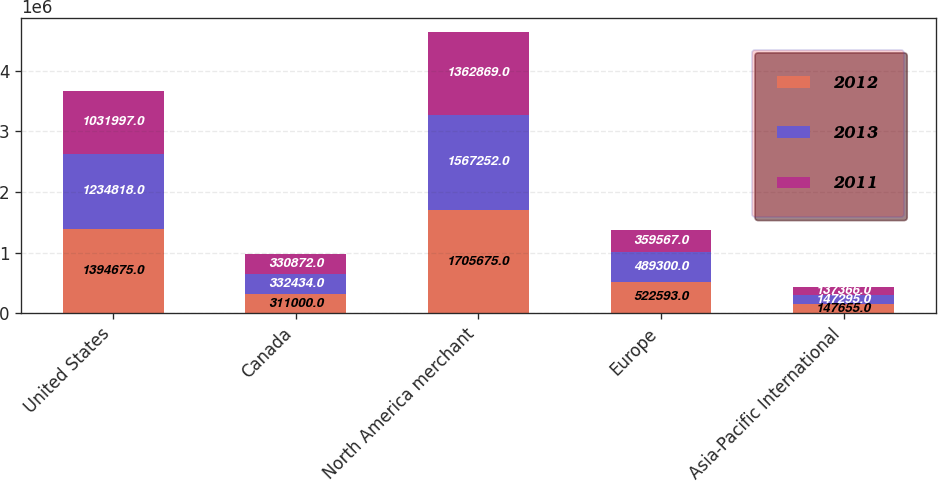Convert chart to OTSL. <chart><loc_0><loc_0><loc_500><loc_500><stacked_bar_chart><ecel><fcel>United States<fcel>Canada<fcel>North America merchant<fcel>Europe<fcel>Asia-Pacific International<nl><fcel>2012<fcel>1.39468e+06<fcel>311000<fcel>1.70568e+06<fcel>522593<fcel>147655<nl><fcel>2013<fcel>1.23482e+06<fcel>332434<fcel>1.56725e+06<fcel>489300<fcel>147295<nl><fcel>2011<fcel>1.032e+06<fcel>330872<fcel>1.36287e+06<fcel>359567<fcel>137366<nl></chart> 